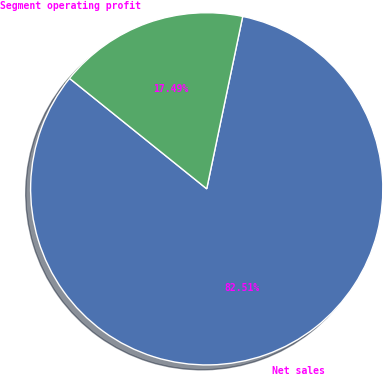Convert chart. <chart><loc_0><loc_0><loc_500><loc_500><pie_chart><fcel>Net sales<fcel>Segment operating profit<nl><fcel>82.51%<fcel>17.49%<nl></chart> 